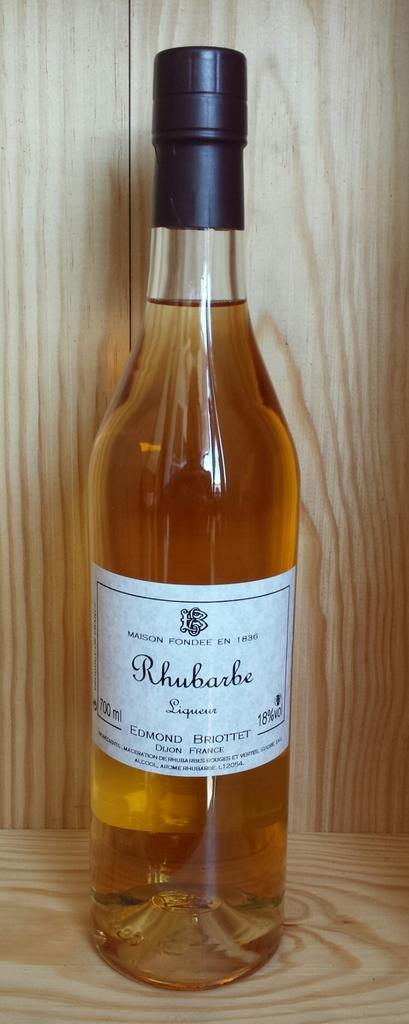<image>
Share a concise interpretation of the image provided. a bottle of maison fondee en 1836 Rhubarbe liqueur 